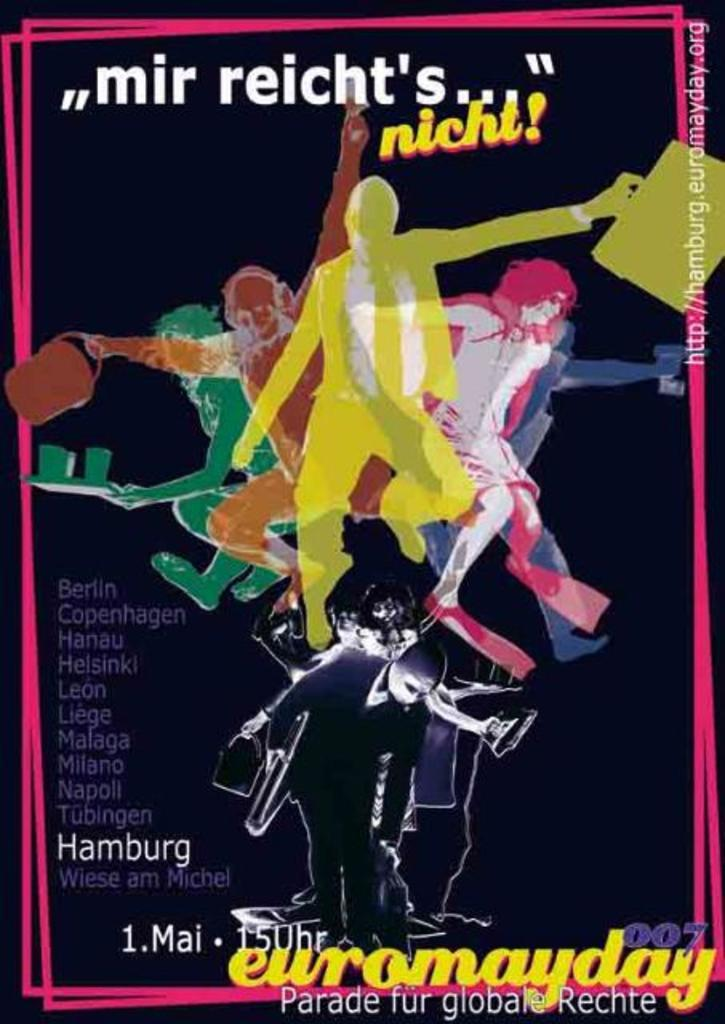<image>
Present a compact description of the photo's key features. A movie type poster advertising "mir reicht's" nicht! 